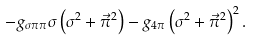Convert formula to latex. <formula><loc_0><loc_0><loc_500><loc_500>- g _ { \sigma \pi \pi } \sigma \left ( \sigma ^ { 2 } + \vec { \pi } ^ { 2 } \right ) - g _ { 4 \pi } \left ( \sigma ^ { 2 } + \vec { \pi } ^ { 2 } \right ) ^ { 2 } .</formula> 